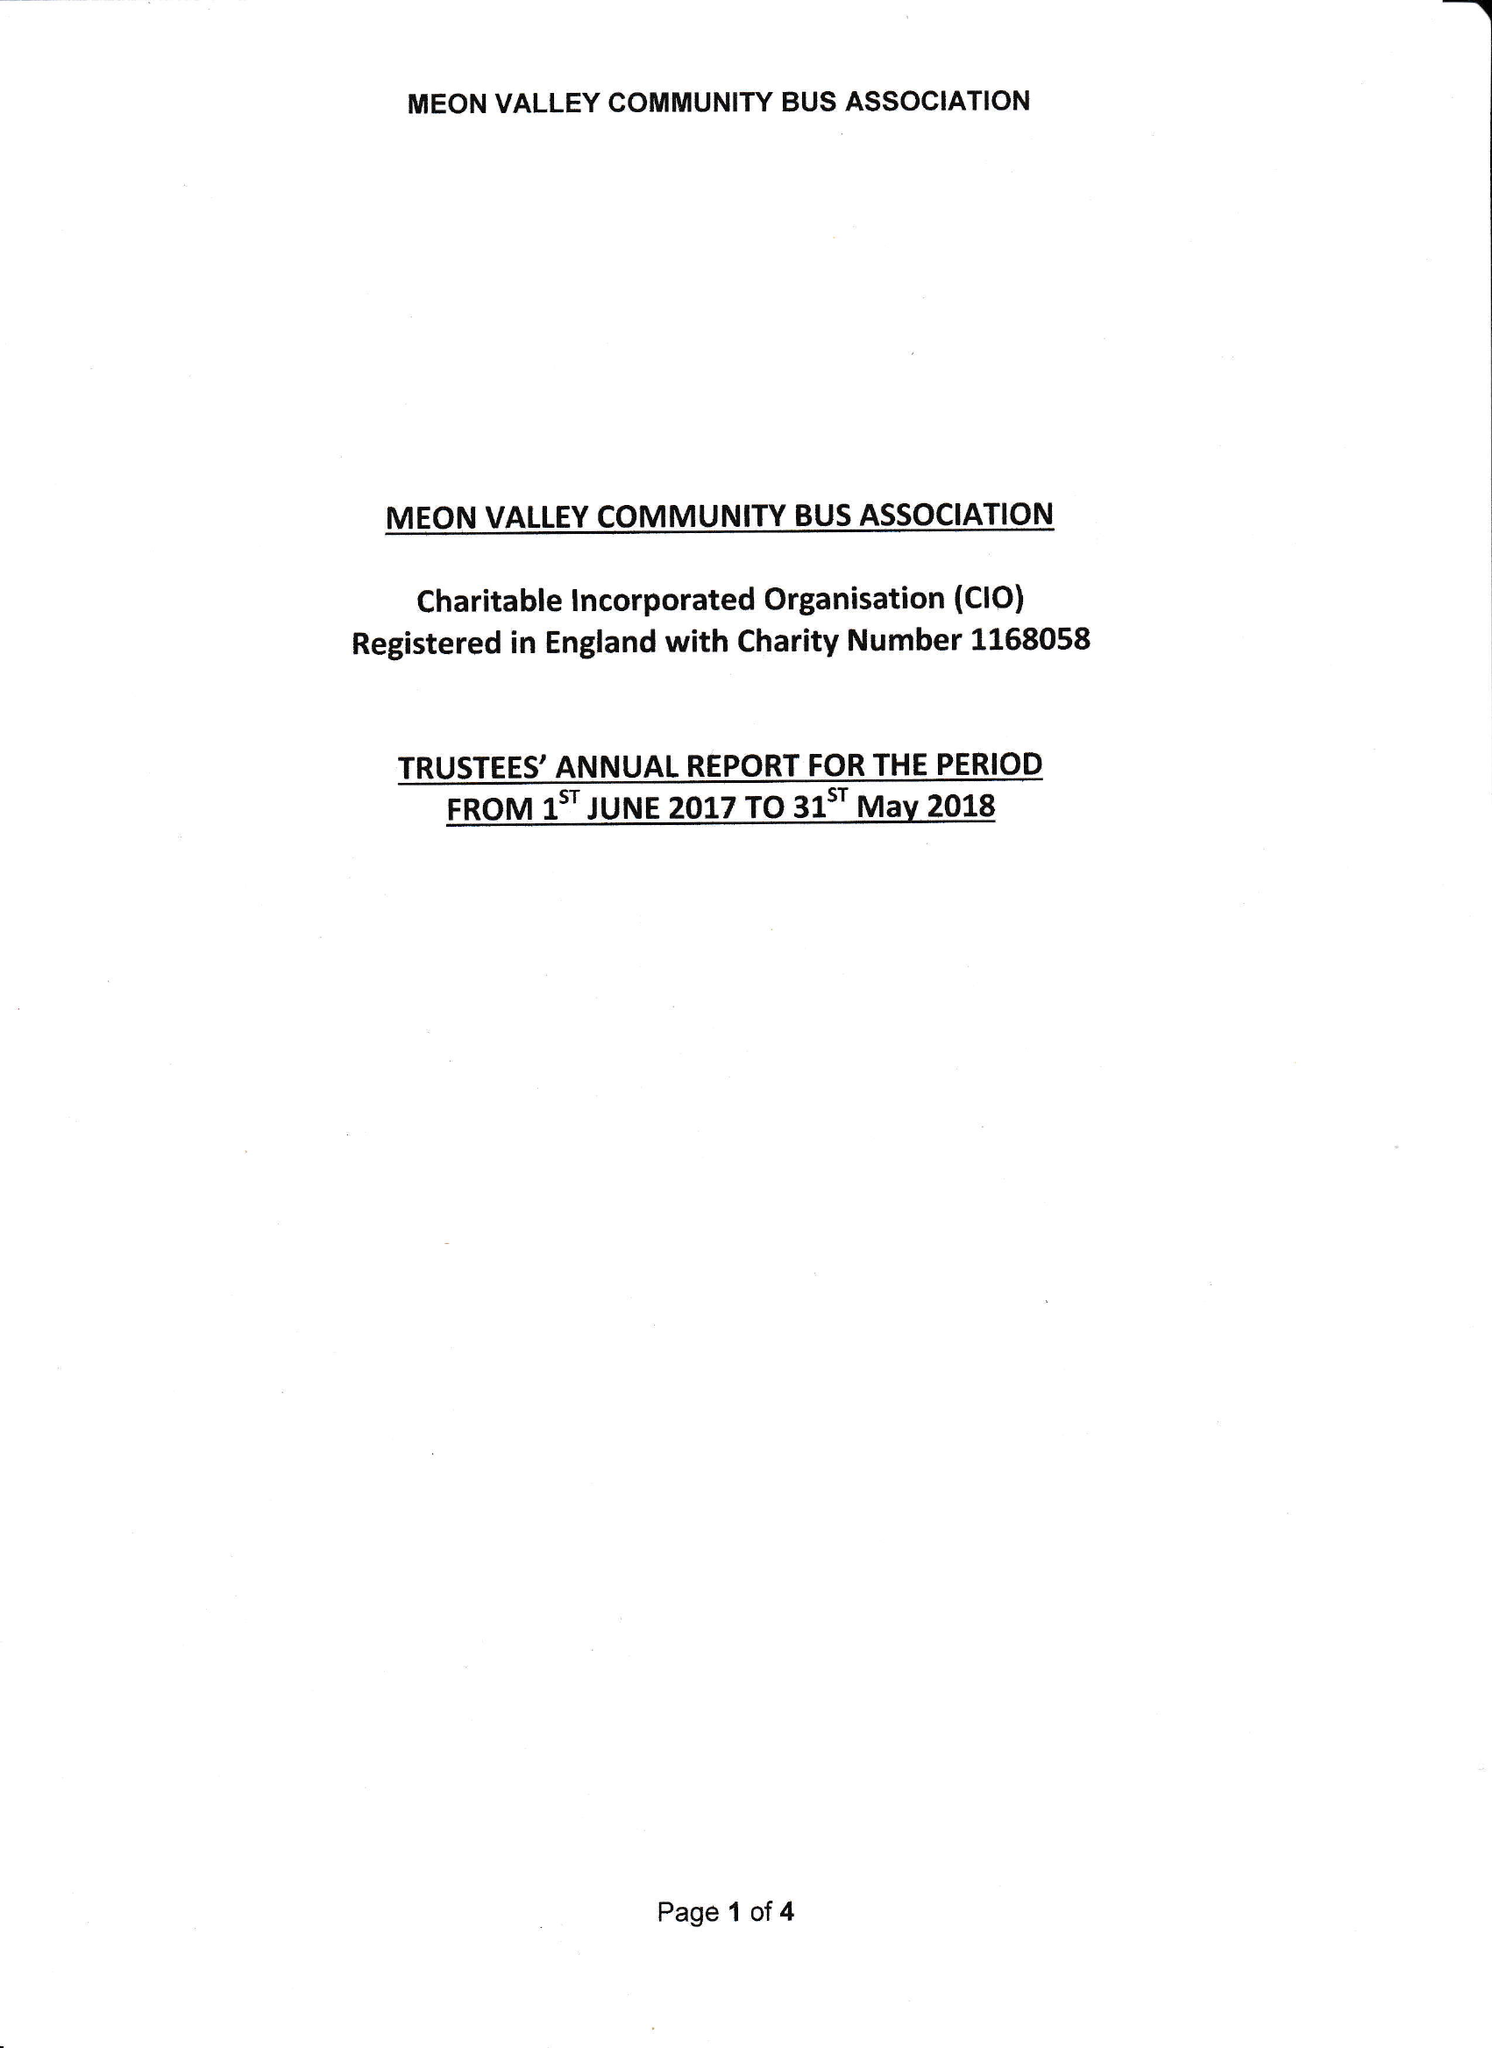What is the value for the income_annually_in_british_pounds?
Answer the question using a single word or phrase. 9540.00 